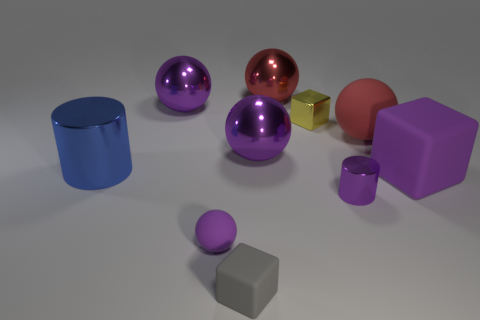Can you describe the arrangement of the shapes in the image based on their size? Certainly! In the image, the shapes are arranged with a range of sizes, from small to large. Starting with the smallest, there's a small grey cube in the foreground. Moving inwards, there's a slightly larger purple sphere, followed by a medium-sized blue cylinder. Progressively larger shapes include a larger purple cube, a large pink sphere, and finally, the largest item is the purple sphere on the left. 